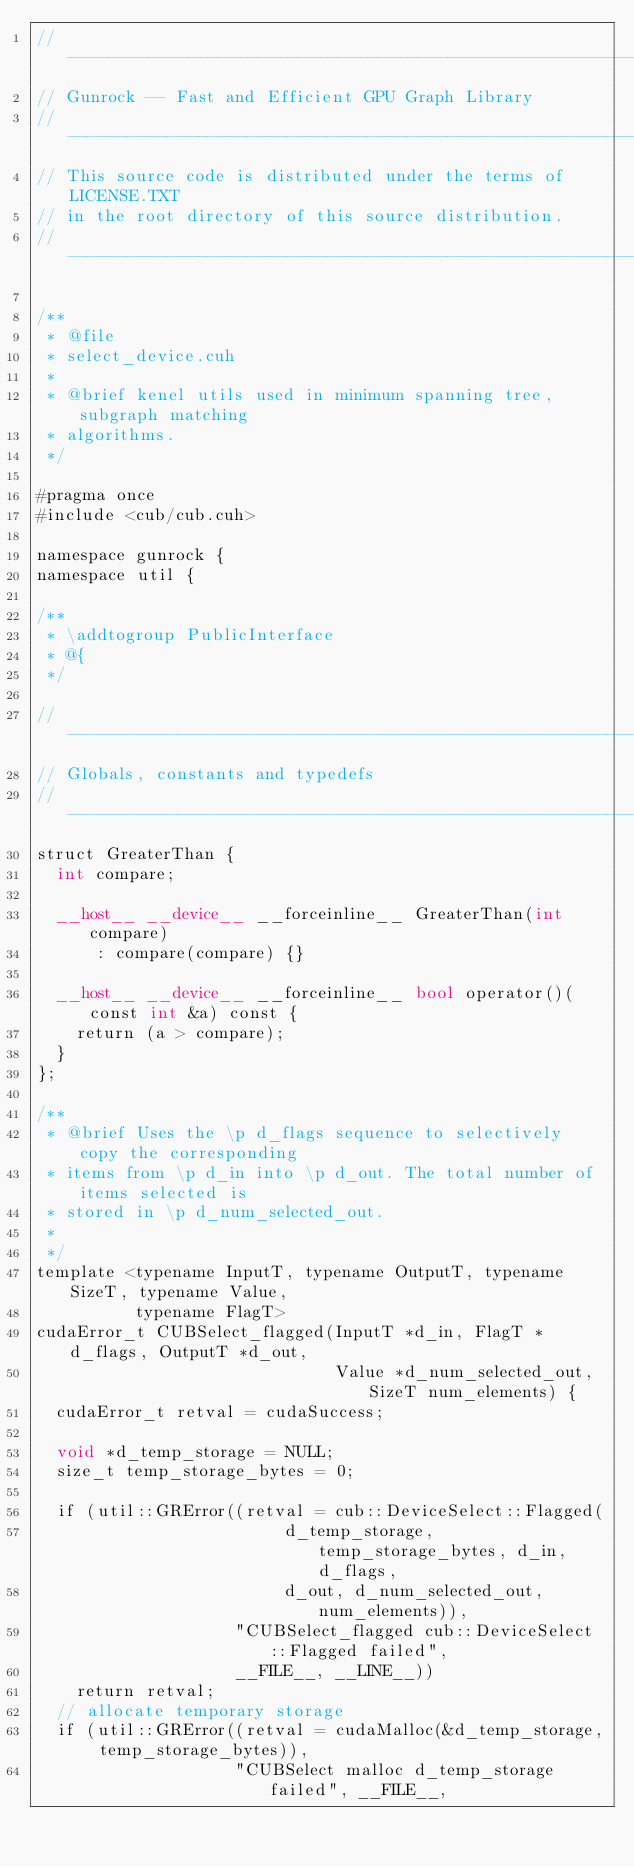Convert code to text. <code><loc_0><loc_0><loc_500><loc_500><_Cuda_>// ----------------------------------------------------------------
// Gunrock -- Fast and Efficient GPU Graph Library
// ----------------------------------------------------------------
// This source code is distributed under the terms of LICENSE.TXT
// in the root directory of this source distribution.
// ----------------------------------------------------------------

/**
 * @file
 * select_device.cuh
 *
 * @brief kenel utils used in minimum spanning tree, subgraph matching
 * algorithms.
 */

#pragma once
#include <cub/cub.cuh>

namespace gunrock {
namespace util {

/**
 * \addtogroup PublicInterface
 * @{
 */

//---------------------------------------------------------------------
// Globals, constants and typedefs
//---------------------------------------------------------------------
struct GreaterThan {
  int compare;

  __host__ __device__ __forceinline__ GreaterThan(int compare)
      : compare(compare) {}

  __host__ __device__ __forceinline__ bool operator()(const int &a) const {
    return (a > compare);
  }
};

/**
 * @brief Uses the \p d_flags sequence to selectively copy the corresponding
 * items from \p d_in into \p d_out. The total number of items selected is
 * stored in \p d_num_selected_out.
 *
 */
template <typename InputT, typename OutputT, typename SizeT, typename Value,
          typename FlagT>
cudaError_t CUBSelect_flagged(InputT *d_in, FlagT *d_flags, OutputT *d_out,
                              Value *d_num_selected_out, SizeT num_elements) {
  cudaError_t retval = cudaSuccess;

  void *d_temp_storage = NULL;
  size_t temp_storage_bytes = 0;

  if (util::GRError((retval = cub::DeviceSelect::Flagged(
                         d_temp_storage, temp_storage_bytes, d_in, d_flags,
                         d_out, d_num_selected_out, num_elements)),
                    "CUBSelect_flagged cub::DeviceSelect::Flagged failed",
                    __FILE__, __LINE__))
    return retval;
  // allocate temporary storage
  if (util::GRError((retval = cudaMalloc(&d_temp_storage, temp_storage_bytes)),
                    "CUBSelect malloc d_temp_storage failed", __FILE__,</code> 